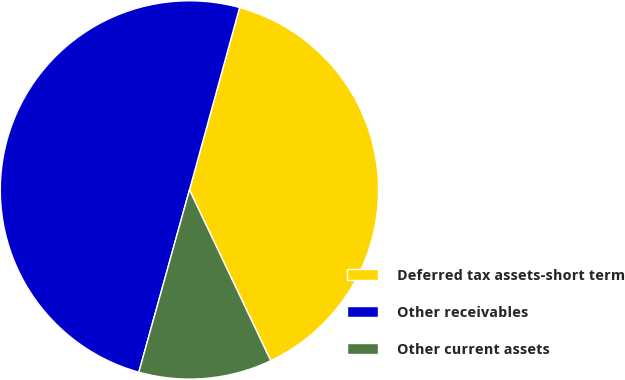<chart> <loc_0><loc_0><loc_500><loc_500><pie_chart><fcel>Deferred tax assets-short term<fcel>Other receivables<fcel>Other current assets<nl><fcel>38.66%<fcel>49.96%<fcel>11.38%<nl></chart> 